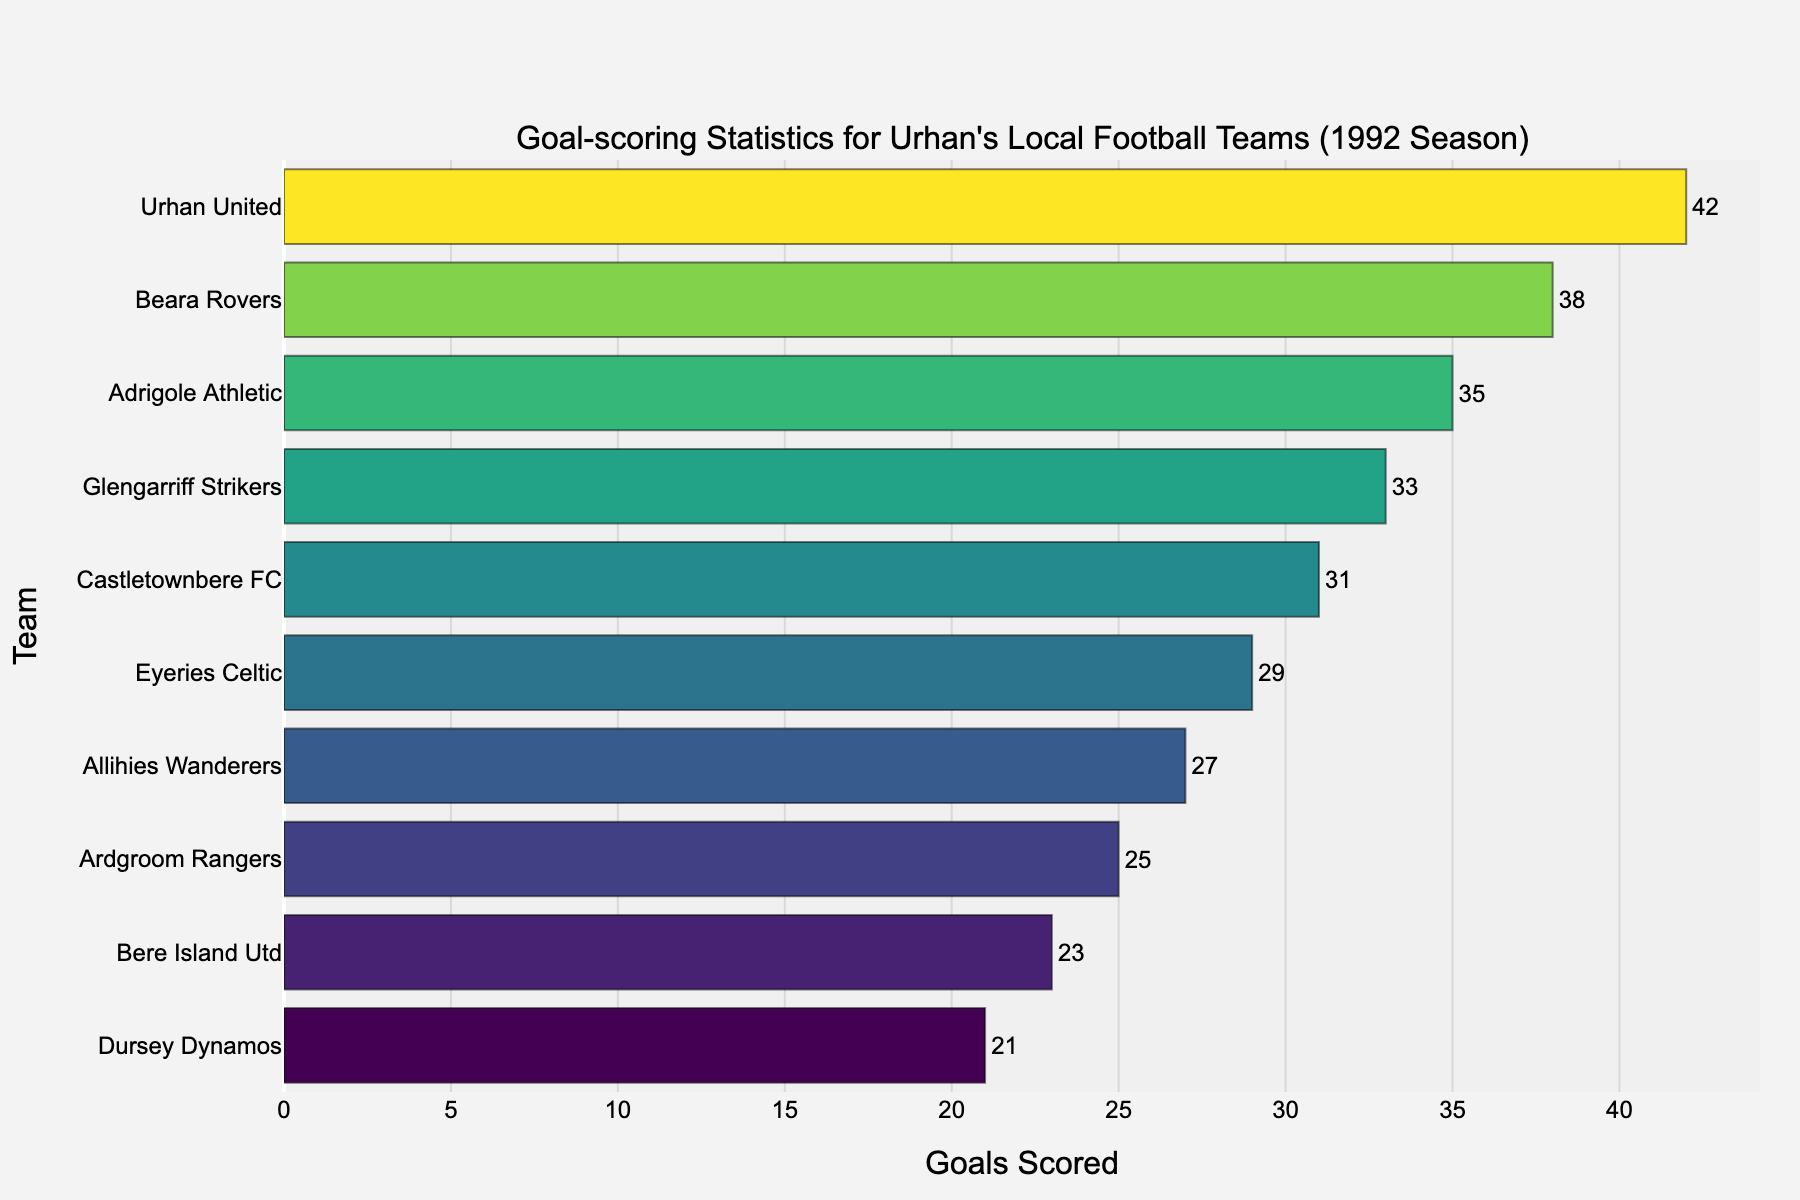What's the total number of goals scored by all teams? To find the total number of goals, sum the goals scored by all teams: 42 (Urhan United) + 38 (Beara Rovers) + 35 (Adrigole Athletic) + 33 (Glengarriff Strikers) + 31 (Castletownbere FC) + 29 (Eyeries Celtic) + 27 (Allihies Wanderers) + 25 (Ardgroom Rangers) + 23 (Bere Island Utd) + 21 (Dursey Dynamos). Adding these gives 304.
Answer: 304 Which team scored the most goals? The team with the highest bar indicates the most goals scored. Urhan United has the highest bar with 42 goals.
Answer: Urhan United How many goals did the third-highest scoring team achieve? The third-highest scoring team is Adrigole Athletic, as they have the third-highest bar. The number of goals they scored is 35.
Answer: 35 What’s the difference in goals scored between the team with the most goals and the team with the fewest? The team with the most goals is Urhan United (42), and the team with the fewest goals is Dursey Dynamos (21). The difference is 42 - 21 = 21.
Answer: 21 Is the number of goals scored by Glengarriff Strikers closer to Beara Rovers or Castletownbere FC? Glengarriff Strikers scored 33 goals. Beara Rovers scored 38, and Castletownbere FC scored 31. Difference with Beara Rovers is 38 - 33 = 5, and with Castletownbere FC is 33 - 31 = 2. As 2 is less than 5, the number of goals scored by Glengarriff Strikers is closer to Castletownbere FC.
Answer: Castletownbere FC Which team scored exactly 27 goals? The bar at the 27-goal level corresponds to Allihies Wanderers.
Answer: Allihies Wanderers Out of all the teams that scored less than 30 goals, which team scored the highest? Teams scoring less than 30 goals: Eyeries Celtic (29), Allihies Wanderers (27), Ardgroom Rangers (25), Bere Island Utd (23), Dursey Dynamos (21). The team with the highest score in this group is Eyeries Celtic with 29 goals.
Answer: Eyeries Celtic How many goals more did Eyeries Celtic score compared to Bere Island Utd? Eyeries Celtic scored 29 goals, and Bere Island Utd scored 23 goals. The difference is 29 - 23 = 6.
Answer: 6 What is the average number of goals scored by all teams? Sum the goals scored by all teams (304) and divide by the number of teams (10). That is 304 ÷ 10 = 30.4.
Answer: 30.4 How many teams scored more than 30 goals? Teams that scored more than 30 goals are Urhan United (42), Beara Rovers (38), Adrigole Athletic (35), Glengarriff Strikers (33), and Castletownbere FC (31). There are 5 such teams.
Answer: 5 